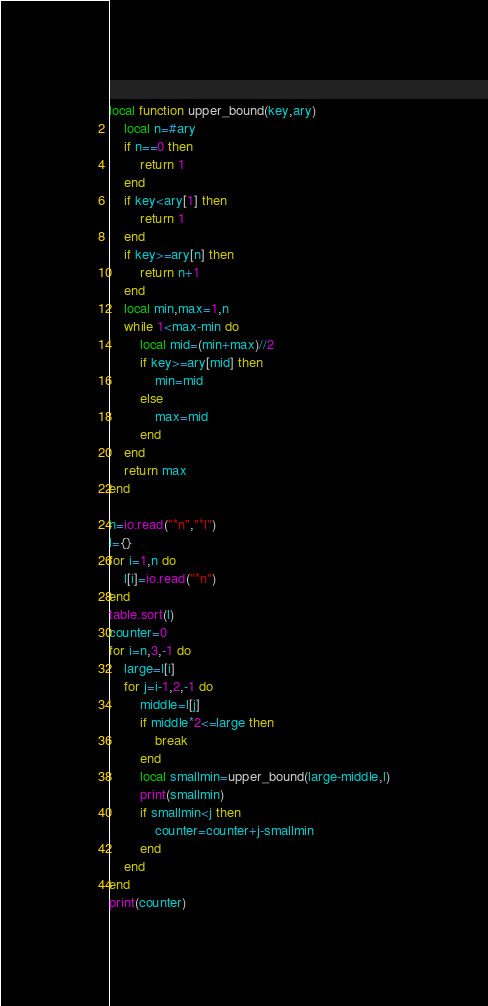Convert code to text. <code><loc_0><loc_0><loc_500><loc_500><_Lua_>local function upper_bound(key,ary)
    local n=#ary
    if n==0 then
        return 1 
    end
    if key<ary[1] then
        return 1
    end
    if key>=ary[n] then
        return n+1
    end
    local min,max=1,n
    while 1<max-min do
        local mid=(min+max)//2
        if key>=ary[mid] then
            min=mid
        else
            max=mid
        end
    end
    return max
end

n=io.read("*n","*l")
l={}
for i=1,n do
    l[i]=io.read("*n")
end
table.sort(l)
counter=0
for i=n,3,-1 do
    large=l[i]
    for j=i-1,2,-1 do
        middle=l[j]
        if middle*2<=large then
            break
        end
        local smallmin=upper_bound(large-middle,l)
        print(smallmin)
        if smallmin<j then
            counter=counter+j-smallmin
        end
    end
end
print(counter)</code> 